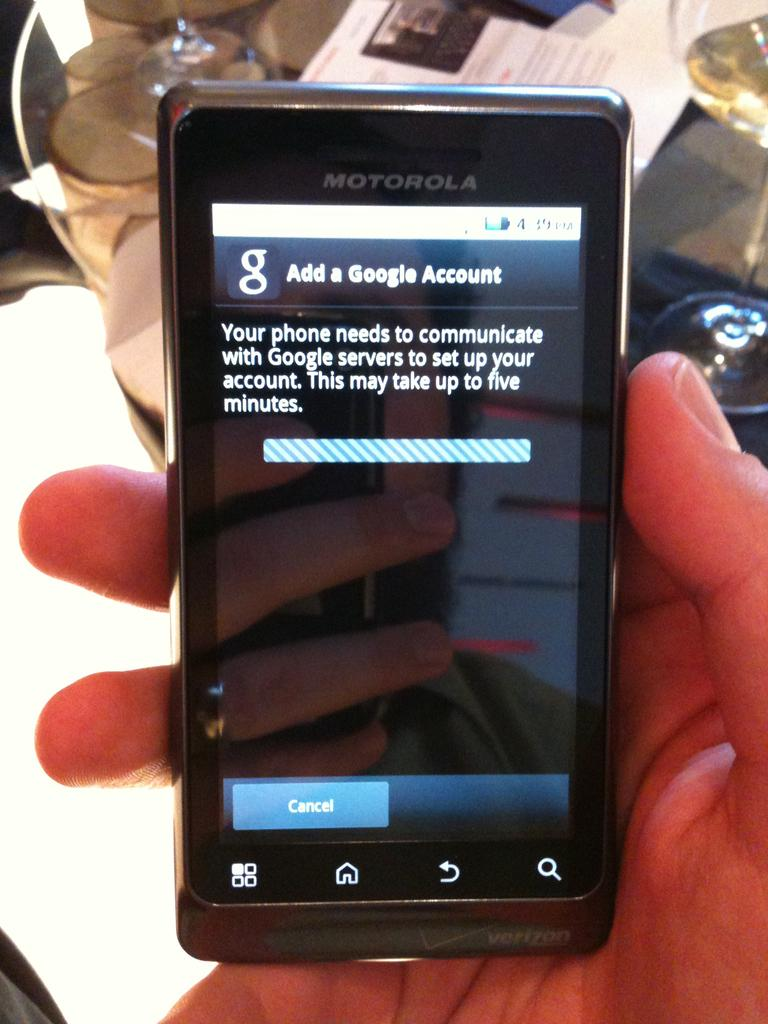Provide a one-sentence caption for the provided image. A Motorola touch screen cell phone bares a message telling the user the add a google account. 